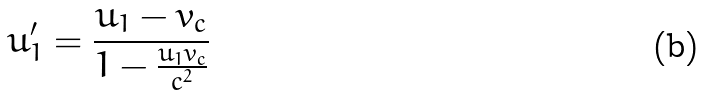Convert formula to latex. <formula><loc_0><loc_0><loc_500><loc_500>u _ { 1 } ^ { \prime } = \frac { u _ { 1 } - v _ { c } } { 1 - \frac { u _ { 1 } v _ { c } } { c ^ { 2 } } }</formula> 